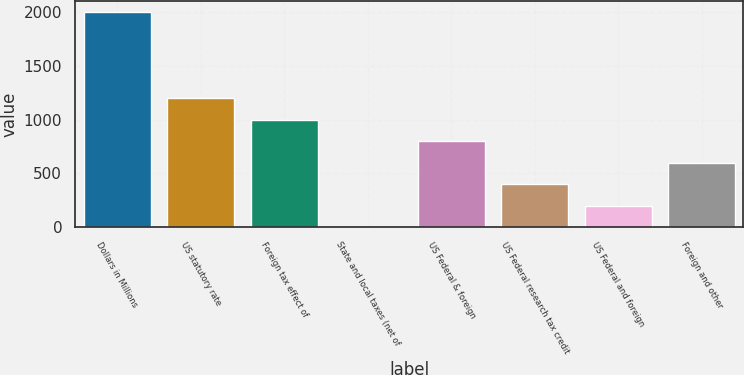Convert chart to OTSL. <chart><loc_0><loc_0><loc_500><loc_500><bar_chart><fcel>Dollars in Millions<fcel>US statutory rate<fcel>Foreign tax effect of<fcel>State and local taxes (net of<fcel>US Federal & foreign<fcel>US Federal research tax credit<fcel>US Federal and foreign<fcel>Foreign and other<nl><fcel>2005<fcel>1203.04<fcel>1002.55<fcel>0.1<fcel>802.06<fcel>401.08<fcel>200.59<fcel>601.57<nl></chart> 